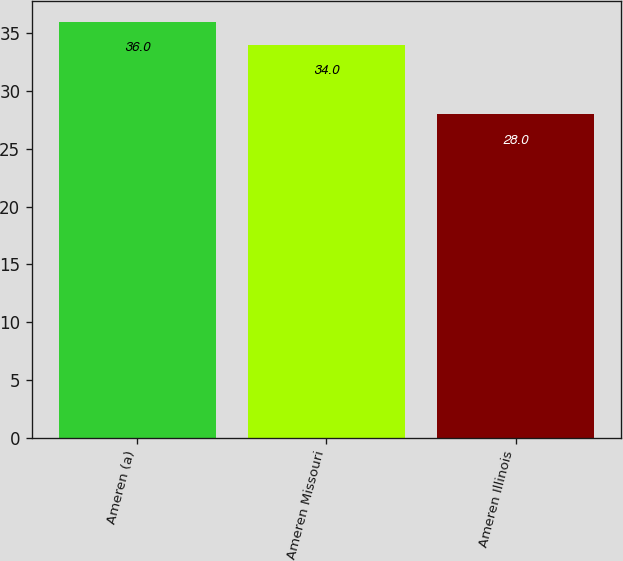<chart> <loc_0><loc_0><loc_500><loc_500><bar_chart><fcel>Ameren (a)<fcel>Ameren Missouri<fcel>Ameren Illinois<nl><fcel>36<fcel>34<fcel>28<nl></chart> 